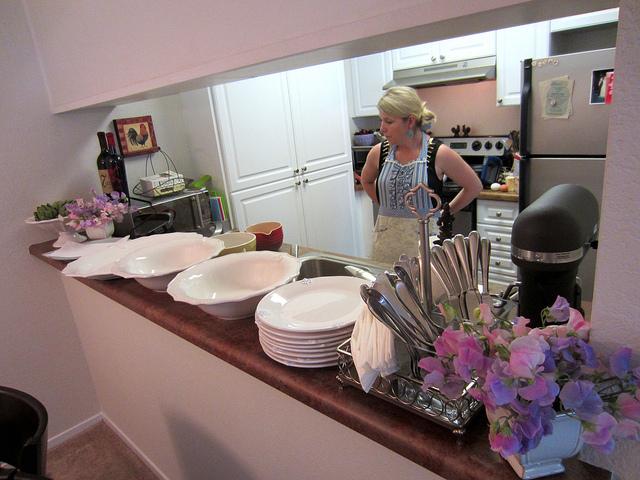What color are the bowls?
Concise answer only. White. Is the kitchen neat?
Write a very short answer. Yes. How many plates are stacked?
Write a very short answer. 8. Did they make a mess?
Keep it brief. No. Is the woman wearing an apron?
Be succinct. Yes. Are those new cabinets?
Short answer required. Yes. What are the circular white things on the right?
Be succinct. Plates. Is it dark?
Give a very brief answer. No. What is in the jars?
Quick response, please. No jars. What color is the refrigerator?
Be succinct. Silver. What type of flowers are in the vase?
Keep it brief. Purple. What color are the flowers on the left wall?
Be succinct. Purple. What color are the two small bowls?
Keep it brief. White. What is the red item under the bowl?
Answer briefly. Counter. Is there wine?
Quick response, please. No. Does the purple flower match the decor?
Short answer required. Yes. What appliance has been used?
Concise answer only. Mixer. How many people are there?
Write a very short answer. 1. What kind of flowers are show?
Answer briefly. 2. Where are the flowers?
Keep it brief. On counter. What color are the plates?
Answer briefly. White. What chips are on the counter?
Concise answer only. None. How many cans are on the bar?
Quick response, please. 0. What is on the counter?
Keep it brief. Plates. Where are the clean plates stacked?
Give a very brief answer. Counter. Are there any muffins?
Answer briefly. No. What are you not supposed to feed?
Quick response, please. Nothing. 